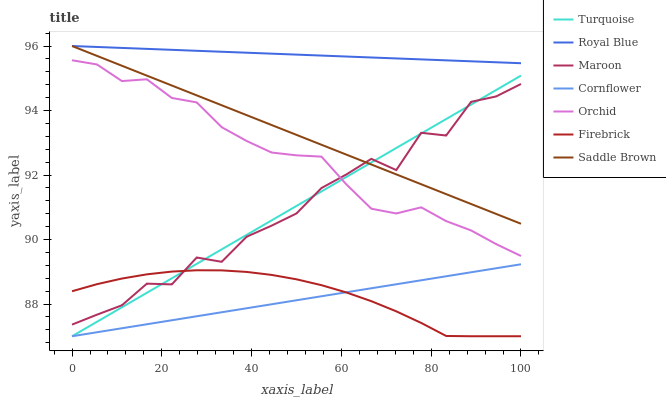Does Turquoise have the minimum area under the curve?
Answer yes or no. No. Does Turquoise have the maximum area under the curve?
Answer yes or no. No. Is Turquoise the smoothest?
Answer yes or no. No. Is Turquoise the roughest?
Answer yes or no. No. Does Maroon have the lowest value?
Answer yes or no. No. Does Turquoise have the highest value?
Answer yes or no. No. Is Firebrick less than Saddle Brown?
Answer yes or no. Yes. Is Orchid greater than Firebrick?
Answer yes or no. Yes. Does Firebrick intersect Saddle Brown?
Answer yes or no. No. 